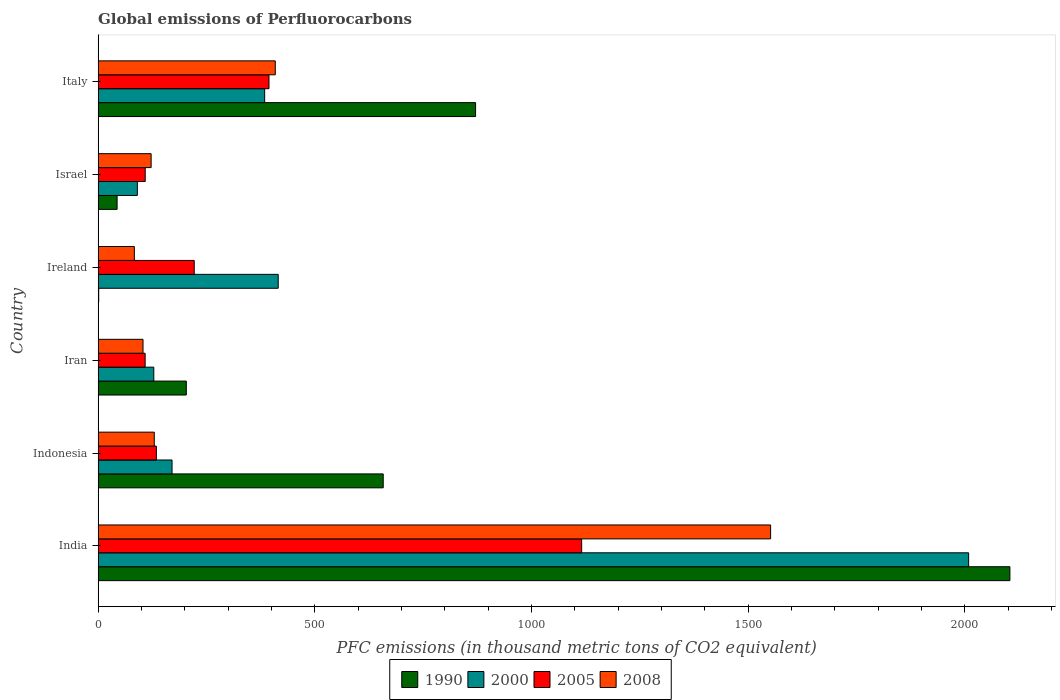How many different coloured bars are there?
Offer a very short reply. 4. How many groups of bars are there?
Your answer should be very brief. 6. Are the number of bars per tick equal to the number of legend labels?
Give a very brief answer. Yes. Are the number of bars on each tick of the Y-axis equal?
Keep it short and to the point. Yes. What is the label of the 1st group of bars from the top?
Give a very brief answer. Italy. In how many cases, is the number of bars for a given country not equal to the number of legend labels?
Keep it short and to the point. 0. What is the global emissions of Perfluorocarbons in 2005 in Israel?
Make the answer very short. 108.7. Across all countries, what is the maximum global emissions of Perfluorocarbons in 2000?
Give a very brief answer. 2008.8. Across all countries, what is the minimum global emissions of Perfluorocarbons in 2008?
Your answer should be compact. 83.6. In which country was the global emissions of Perfluorocarbons in 1990 minimum?
Make the answer very short. Ireland. What is the total global emissions of Perfluorocarbons in 2000 in the graph?
Provide a succinct answer. 3198.3. What is the difference between the global emissions of Perfluorocarbons in 2000 in India and that in Israel?
Your answer should be very brief. 1918.3. What is the difference between the global emissions of Perfluorocarbons in 2008 in Iran and the global emissions of Perfluorocarbons in 2005 in Indonesia?
Make the answer very short. -30.8. What is the average global emissions of Perfluorocarbons in 2005 per country?
Make the answer very short. 347.25. What is the difference between the global emissions of Perfluorocarbons in 1990 and global emissions of Perfluorocarbons in 2008 in Israel?
Provide a succinct answer. -78.5. In how many countries, is the global emissions of Perfluorocarbons in 1990 greater than 100 thousand metric tons?
Give a very brief answer. 4. What is the ratio of the global emissions of Perfluorocarbons in 1990 in Indonesia to that in Ireland?
Your answer should be compact. 469.93. What is the difference between the highest and the second highest global emissions of Perfluorocarbons in 1990?
Offer a terse response. 1233. What is the difference between the highest and the lowest global emissions of Perfluorocarbons in 2008?
Ensure brevity in your answer.  1468.2. In how many countries, is the global emissions of Perfluorocarbons in 2005 greater than the average global emissions of Perfluorocarbons in 2005 taken over all countries?
Your answer should be very brief. 2. Is the sum of the global emissions of Perfluorocarbons in 1990 in Indonesia and Ireland greater than the maximum global emissions of Perfluorocarbons in 2008 across all countries?
Your answer should be compact. No. What does the 4th bar from the bottom in Israel represents?
Your response must be concise. 2008. Is it the case that in every country, the sum of the global emissions of Perfluorocarbons in 2005 and global emissions of Perfluorocarbons in 2000 is greater than the global emissions of Perfluorocarbons in 2008?
Your answer should be compact. Yes. How many bars are there?
Offer a terse response. 24. How many countries are there in the graph?
Provide a short and direct response. 6. Are the values on the major ticks of X-axis written in scientific E-notation?
Ensure brevity in your answer.  No. Where does the legend appear in the graph?
Your response must be concise. Bottom center. How many legend labels are there?
Offer a very short reply. 4. What is the title of the graph?
Your answer should be very brief. Global emissions of Perfluorocarbons. Does "1988" appear as one of the legend labels in the graph?
Ensure brevity in your answer.  No. What is the label or title of the X-axis?
Provide a succinct answer. PFC emissions (in thousand metric tons of CO2 equivalent). What is the label or title of the Y-axis?
Provide a short and direct response. Country. What is the PFC emissions (in thousand metric tons of CO2 equivalent) in 1990 in India?
Offer a very short reply. 2104. What is the PFC emissions (in thousand metric tons of CO2 equivalent) of 2000 in India?
Your answer should be very brief. 2008.8. What is the PFC emissions (in thousand metric tons of CO2 equivalent) of 2005 in India?
Your response must be concise. 1115.8. What is the PFC emissions (in thousand metric tons of CO2 equivalent) of 2008 in India?
Your answer should be very brief. 1551.8. What is the PFC emissions (in thousand metric tons of CO2 equivalent) of 1990 in Indonesia?
Offer a terse response. 657.9. What is the PFC emissions (in thousand metric tons of CO2 equivalent) of 2000 in Indonesia?
Keep it short and to the point. 170.6. What is the PFC emissions (in thousand metric tons of CO2 equivalent) of 2005 in Indonesia?
Your answer should be very brief. 134.4. What is the PFC emissions (in thousand metric tons of CO2 equivalent) in 2008 in Indonesia?
Ensure brevity in your answer.  129.6. What is the PFC emissions (in thousand metric tons of CO2 equivalent) in 1990 in Iran?
Make the answer very short. 203.5. What is the PFC emissions (in thousand metric tons of CO2 equivalent) of 2000 in Iran?
Provide a short and direct response. 128.5. What is the PFC emissions (in thousand metric tons of CO2 equivalent) of 2005 in Iran?
Your response must be concise. 108.5. What is the PFC emissions (in thousand metric tons of CO2 equivalent) in 2008 in Iran?
Make the answer very short. 103.6. What is the PFC emissions (in thousand metric tons of CO2 equivalent) of 2000 in Ireland?
Your answer should be compact. 415.6. What is the PFC emissions (in thousand metric tons of CO2 equivalent) in 2005 in Ireland?
Your response must be concise. 221.8. What is the PFC emissions (in thousand metric tons of CO2 equivalent) in 2008 in Ireland?
Offer a very short reply. 83.6. What is the PFC emissions (in thousand metric tons of CO2 equivalent) in 1990 in Israel?
Your answer should be compact. 43.8. What is the PFC emissions (in thousand metric tons of CO2 equivalent) in 2000 in Israel?
Offer a terse response. 90.5. What is the PFC emissions (in thousand metric tons of CO2 equivalent) in 2005 in Israel?
Ensure brevity in your answer.  108.7. What is the PFC emissions (in thousand metric tons of CO2 equivalent) in 2008 in Israel?
Offer a very short reply. 122.3. What is the PFC emissions (in thousand metric tons of CO2 equivalent) in 1990 in Italy?
Offer a very short reply. 871. What is the PFC emissions (in thousand metric tons of CO2 equivalent) in 2000 in Italy?
Your answer should be very brief. 384.3. What is the PFC emissions (in thousand metric tons of CO2 equivalent) of 2005 in Italy?
Ensure brevity in your answer.  394.3. What is the PFC emissions (in thousand metric tons of CO2 equivalent) of 2008 in Italy?
Your answer should be very brief. 408.8. Across all countries, what is the maximum PFC emissions (in thousand metric tons of CO2 equivalent) in 1990?
Your answer should be compact. 2104. Across all countries, what is the maximum PFC emissions (in thousand metric tons of CO2 equivalent) of 2000?
Provide a short and direct response. 2008.8. Across all countries, what is the maximum PFC emissions (in thousand metric tons of CO2 equivalent) of 2005?
Your response must be concise. 1115.8. Across all countries, what is the maximum PFC emissions (in thousand metric tons of CO2 equivalent) of 2008?
Give a very brief answer. 1551.8. Across all countries, what is the minimum PFC emissions (in thousand metric tons of CO2 equivalent) of 2000?
Your answer should be compact. 90.5. Across all countries, what is the minimum PFC emissions (in thousand metric tons of CO2 equivalent) in 2005?
Provide a short and direct response. 108.5. Across all countries, what is the minimum PFC emissions (in thousand metric tons of CO2 equivalent) in 2008?
Keep it short and to the point. 83.6. What is the total PFC emissions (in thousand metric tons of CO2 equivalent) of 1990 in the graph?
Keep it short and to the point. 3881.6. What is the total PFC emissions (in thousand metric tons of CO2 equivalent) in 2000 in the graph?
Your response must be concise. 3198.3. What is the total PFC emissions (in thousand metric tons of CO2 equivalent) of 2005 in the graph?
Make the answer very short. 2083.5. What is the total PFC emissions (in thousand metric tons of CO2 equivalent) of 2008 in the graph?
Your response must be concise. 2399.7. What is the difference between the PFC emissions (in thousand metric tons of CO2 equivalent) of 1990 in India and that in Indonesia?
Ensure brevity in your answer.  1446.1. What is the difference between the PFC emissions (in thousand metric tons of CO2 equivalent) in 2000 in India and that in Indonesia?
Ensure brevity in your answer.  1838.2. What is the difference between the PFC emissions (in thousand metric tons of CO2 equivalent) in 2005 in India and that in Indonesia?
Keep it short and to the point. 981.4. What is the difference between the PFC emissions (in thousand metric tons of CO2 equivalent) in 2008 in India and that in Indonesia?
Offer a terse response. 1422.2. What is the difference between the PFC emissions (in thousand metric tons of CO2 equivalent) of 1990 in India and that in Iran?
Offer a terse response. 1900.5. What is the difference between the PFC emissions (in thousand metric tons of CO2 equivalent) in 2000 in India and that in Iran?
Provide a succinct answer. 1880.3. What is the difference between the PFC emissions (in thousand metric tons of CO2 equivalent) in 2005 in India and that in Iran?
Give a very brief answer. 1007.3. What is the difference between the PFC emissions (in thousand metric tons of CO2 equivalent) of 2008 in India and that in Iran?
Give a very brief answer. 1448.2. What is the difference between the PFC emissions (in thousand metric tons of CO2 equivalent) of 1990 in India and that in Ireland?
Provide a short and direct response. 2102.6. What is the difference between the PFC emissions (in thousand metric tons of CO2 equivalent) of 2000 in India and that in Ireland?
Offer a terse response. 1593.2. What is the difference between the PFC emissions (in thousand metric tons of CO2 equivalent) in 2005 in India and that in Ireland?
Offer a terse response. 894. What is the difference between the PFC emissions (in thousand metric tons of CO2 equivalent) of 2008 in India and that in Ireland?
Offer a very short reply. 1468.2. What is the difference between the PFC emissions (in thousand metric tons of CO2 equivalent) in 1990 in India and that in Israel?
Make the answer very short. 2060.2. What is the difference between the PFC emissions (in thousand metric tons of CO2 equivalent) in 2000 in India and that in Israel?
Offer a very short reply. 1918.3. What is the difference between the PFC emissions (in thousand metric tons of CO2 equivalent) in 2005 in India and that in Israel?
Offer a very short reply. 1007.1. What is the difference between the PFC emissions (in thousand metric tons of CO2 equivalent) of 2008 in India and that in Israel?
Offer a very short reply. 1429.5. What is the difference between the PFC emissions (in thousand metric tons of CO2 equivalent) of 1990 in India and that in Italy?
Make the answer very short. 1233. What is the difference between the PFC emissions (in thousand metric tons of CO2 equivalent) in 2000 in India and that in Italy?
Make the answer very short. 1624.5. What is the difference between the PFC emissions (in thousand metric tons of CO2 equivalent) of 2005 in India and that in Italy?
Your response must be concise. 721.5. What is the difference between the PFC emissions (in thousand metric tons of CO2 equivalent) of 2008 in India and that in Italy?
Your response must be concise. 1143. What is the difference between the PFC emissions (in thousand metric tons of CO2 equivalent) in 1990 in Indonesia and that in Iran?
Give a very brief answer. 454.4. What is the difference between the PFC emissions (in thousand metric tons of CO2 equivalent) in 2000 in Indonesia and that in Iran?
Provide a succinct answer. 42.1. What is the difference between the PFC emissions (in thousand metric tons of CO2 equivalent) of 2005 in Indonesia and that in Iran?
Give a very brief answer. 25.9. What is the difference between the PFC emissions (in thousand metric tons of CO2 equivalent) in 2008 in Indonesia and that in Iran?
Your answer should be very brief. 26. What is the difference between the PFC emissions (in thousand metric tons of CO2 equivalent) in 1990 in Indonesia and that in Ireland?
Provide a succinct answer. 656.5. What is the difference between the PFC emissions (in thousand metric tons of CO2 equivalent) in 2000 in Indonesia and that in Ireland?
Give a very brief answer. -245. What is the difference between the PFC emissions (in thousand metric tons of CO2 equivalent) in 2005 in Indonesia and that in Ireland?
Keep it short and to the point. -87.4. What is the difference between the PFC emissions (in thousand metric tons of CO2 equivalent) of 1990 in Indonesia and that in Israel?
Keep it short and to the point. 614.1. What is the difference between the PFC emissions (in thousand metric tons of CO2 equivalent) in 2000 in Indonesia and that in Israel?
Ensure brevity in your answer.  80.1. What is the difference between the PFC emissions (in thousand metric tons of CO2 equivalent) of 2005 in Indonesia and that in Israel?
Offer a very short reply. 25.7. What is the difference between the PFC emissions (in thousand metric tons of CO2 equivalent) in 1990 in Indonesia and that in Italy?
Keep it short and to the point. -213.1. What is the difference between the PFC emissions (in thousand metric tons of CO2 equivalent) in 2000 in Indonesia and that in Italy?
Ensure brevity in your answer.  -213.7. What is the difference between the PFC emissions (in thousand metric tons of CO2 equivalent) of 2005 in Indonesia and that in Italy?
Your answer should be very brief. -259.9. What is the difference between the PFC emissions (in thousand metric tons of CO2 equivalent) in 2008 in Indonesia and that in Italy?
Your answer should be compact. -279.2. What is the difference between the PFC emissions (in thousand metric tons of CO2 equivalent) of 1990 in Iran and that in Ireland?
Your answer should be very brief. 202.1. What is the difference between the PFC emissions (in thousand metric tons of CO2 equivalent) in 2000 in Iran and that in Ireland?
Make the answer very short. -287.1. What is the difference between the PFC emissions (in thousand metric tons of CO2 equivalent) of 2005 in Iran and that in Ireland?
Make the answer very short. -113.3. What is the difference between the PFC emissions (in thousand metric tons of CO2 equivalent) of 1990 in Iran and that in Israel?
Offer a very short reply. 159.7. What is the difference between the PFC emissions (in thousand metric tons of CO2 equivalent) in 2005 in Iran and that in Israel?
Keep it short and to the point. -0.2. What is the difference between the PFC emissions (in thousand metric tons of CO2 equivalent) in 2008 in Iran and that in Israel?
Your response must be concise. -18.7. What is the difference between the PFC emissions (in thousand metric tons of CO2 equivalent) in 1990 in Iran and that in Italy?
Offer a terse response. -667.5. What is the difference between the PFC emissions (in thousand metric tons of CO2 equivalent) of 2000 in Iran and that in Italy?
Provide a succinct answer. -255.8. What is the difference between the PFC emissions (in thousand metric tons of CO2 equivalent) of 2005 in Iran and that in Italy?
Your response must be concise. -285.8. What is the difference between the PFC emissions (in thousand metric tons of CO2 equivalent) in 2008 in Iran and that in Italy?
Provide a succinct answer. -305.2. What is the difference between the PFC emissions (in thousand metric tons of CO2 equivalent) in 1990 in Ireland and that in Israel?
Provide a short and direct response. -42.4. What is the difference between the PFC emissions (in thousand metric tons of CO2 equivalent) of 2000 in Ireland and that in Israel?
Your response must be concise. 325.1. What is the difference between the PFC emissions (in thousand metric tons of CO2 equivalent) of 2005 in Ireland and that in Israel?
Your answer should be compact. 113.1. What is the difference between the PFC emissions (in thousand metric tons of CO2 equivalent) of 2008 in Ireland and that in Israel?
Provide a short and direct response. -38.7. What is the difference between the PFC emissions (in thousand metric tons of CO2 equivalent) of 1990 in Ireland and that in Italy?
Provide a short and direct response. -869.6. What is the difference between the PFC emissions (in thousand metric tons of CO2 equivalent) of 2000 in Ireland and that in Italy?
Give a very brief answer. 31.3. What is the difference between the PFC emissions (in thousand metric tons of CO2 equivalent) in 2005 in Ireland and that in Italy?
Your answer should be very brief. -172.5. What is the difference between the PFC emissions (in thousand metric tons of CO2 equivalent) of 2008 in Ireland and that in Italy?
Your response must be concise. -325.2. What is the difference between the PFC emissions (in thousand metric tons of CO2 equivalent) of 1990 in Israel and that in Italy?
Your answer should be compact. -827.2. What is the difference between the PFC emissions (in thousand metric tons of CO2 equivalent) of 2000 in Israel and that in Italy?
Give a very brief answer. -293.8. What is the difference between the PFC emissions (in thousand metric tons of CO2 equivalent) of 2005 in Israel and that in Italy?
Your response must be concise. -285.6. What is the difference between the PFC emissions (in thousand metric tons of CO2 equivalent) in 2008 in Israel and that in Italy?
Your answer should be very brief. -286.5. What is the difference between the PFC emissions (in thousand metric tons of CO2 equivalent) of 1990 in India and the PFC emissions (in thousand metric tons of CO2 equivalent) of 2000 in Indonesia?
Your answer should be very brief. 1933.4. What is the difference between the PFC emissions (in thousand metric tons of CO2 equivalent) in 1990 in India and the PFC emissions (in thousand metric tons of CO2 equivalent) in 2005 in Indonesia?
Provide a short and direct response. 1969.6. What is the difference between the PFC emissions (in thousand metric tons of CO2 equivalent) of 1990 in India and the PFC emissions (in thousand metric tons of CO2 equivalent) of 2008 in Indonesia?
Offer a terse response. 1974.4. What is the difference between the PFC emissions (in thousand metric tons of CO2 equivalent) of 2000 in India and the PFC emissions (in thousand metric tons of CO2 equivalent) of 2005 in Indonesia?
Offer a very short reply. 1874.4. What is the difference between the PFC emissions (in thousand metric tons of CO2 equivalent) of 2000 in India and the PFC emissions (in thousand metric tons of CO2 equivalent) of 2008 in Indonesia?
Your response must be concise. 1879.2. What is the difference between the PFC emissions (in thousand metric tons of CO2 equivalent) in 2005 in India and the PFC emissions (in thousand metric tons of CO2 equivalent) in 2008 in Indonesia?
Make the answer very short. 986.2. What is the difference between the PFC emissions (in thousand metric tons of CO2 equivalent) of 1990 in India and the PFC emissions (in thousand metric tons of CO2 equivalent) of 2000 in Iran?
Provide a succinct answer. 1975.5. What is the difference between the PFC emissions (in thousand metric tons of CO2 equivalent) of 1990 in India and the PFC emissions (in thousand metric tons of CO2 equivalent) of 2005 in Iran?
Offer a very short reply. 1995.5. What is the difference between the PFC emissions (in thousand metric tons of CO2 equivalent) in 1990 in India and the PFC emissions (in thousand metric tons of CO2 equivalent) in 2008 in Iran?
Provide a short and direct response. 2000.4. What is the difference between the PFC emissions (in thousand metric tons of CO2 equivalent) of 2000 in India and the PFC emissions (in thousand metric tons of CO2 equivalent) of 2005 in Iran?
Offer a very short reply. 1900.3. What is the difference between the PFC emissions (in thousand metric tons of CO2 equivalent) in 2000 in India and the PFC emissions (in thousand metric tons of CO2 equivalent) in 2008 in Iran?
Your response must be concise. 1905.2. What is the difference between the PFC emissions (in thousand metric tons of CO2 equivalent) of 2005 in India and the PFC emissions (in thousand metric tons of CO2 equivalent) of 2008 in Iran?
Keep it short and to the point. 1012.2. What is the difference between the PFC emissions (in thousand metric tons of CO2 equivalent) of 1990 in India and the PFC emissions (in thousand metric tons of CO2 equivalent) of 2000 in Ireland?
Offer a very short reply. 1688.4. What is the difference between the PFC emissions (in thousand metric tons of CO2 equivalent) of 1990 in India and the PFC emissions (in thousand metric tons of CO2 equivalent) of 2005 in Ireland?
Your answer should be compact. 1882.2. What is the difference between the PFC emissions (in thousand metric tons of CO2 equivalent) in 1990 in India and the PFC emissions (in thousand metric tons of CO2 equivalent) in 2008 in Ireland?
Provide a succinct answer. 2020.4. What is the difference between the PFC emissions (in thousand metric tons of CO2 equivalent) in 2000 in India and the PFC emissions (in thousand metric tons of CO2 equivalent) in 2005 in Ireland?
Offer a very short reply. 1787. What is the difference between the PFC emissions (in thousand metric tons of CO2 equivalent) in 2000 in India and the PFC emissions (in thousand metric tons of CO2 equivalent) in 2008 in Ireland?
Your answer should be compact. 1925.2. What is the difference between the PFC emissions (in thousand metric tons of CO2 equivalent) of 2005 in India and the PFC emissions (in thousand metric tons of CO2 equivalent) of 2008 in Ireland?
Provide a short and direct response. 1032.2. What is the difference between the PFC emissions (in thousand metric tons of CO2 equivalent) in 1990 in India and the PFC emissions (in thousand metric tons of CO2 equivalent) in 2000 in Israel?
Keep it short and to the point. 2013.5. What is the difference between the PFC emissions (in thousand metric tons of CO2 equivalent) in 1990 in India and the PFC emissions (in thousand metric tons of CO2 equivalent) in 2005 in Israel?
Offer a terse response. 1995.3. What is the difference between the PFC emissions (in thousand metric tons of CO2 equivalent) in 1990 in India and the PFC emissions (in thousand metric tons of CO2 equivalent) in 2008 in Israel?
Offer a terse response. 1981.7. What is the difference between the PFC emissions (in thousand metric tons of CO2 equivalent) in 2000 in India and the PFC emissions (in thousand metric tons of CO2 equivalent) in 2005 in Israel?
Make the answer very short. 1900.1. What is the difference between the PFC emissions (in thousand metric tons of CO2 equivalent) in 2000 in India and the PFC emissions (in thousand metric tons of CO2 equivalent) in 2008 in Israel?
Your response must be concise. 1886.5. What is the difference between the PFC emissions (in thousand metric tons of CO2 equivalent) of 2005 in India and the PFC emissions (in thousand metric tons of CO2 equivalent) of 2008 in Israel?
Your response must be concise. 993.5. What is the difference between the PFC emissions (in thousand metric tons of CO2 equivalent) in 1990 in India and the PFC emissions (in thousand metric tons of CO2 equivalent) in 2000 in Italy?
Your response must be concise. 1719.7. What is the difference between the PFC emissions (in thousand metric tons of CO2 equivalent) of 1990 in India and the PFC emissions (in thousand metric tons of CO2 equivalent) of 2005 in Italy?
Your answer should be very brief. 1709.7. What is the difference between the PFC emissions (in thousand metric tons of CO2 equivalent) in 1990 in India and the PFC emissions (in thousand metric tons of CO2 equivalent) in 2008 in Italy?
Offer a very short reply. 1695.2. What is the difference between the PFC emissions (in thousand metric tons of CO2 equivalent) of 2000 in India and the PFC emissions (in thousand metric tons of CO2 equivalent) of 2005 in Italy?
Provide a short and direct response. 1614.5. What is the difference between the PFC emissions (in thousand metric tons of CO2 equivalent) in 2000 in India and the PFC emissions (in thousand metric tons of CO2 equivalent) in 2008 in Italy?
Provide a succinct answer. 1600. What is the difference between the PFC emissions (in thousand metric tons of CO2 equivalent) of 2005 in India and the PFC emissions (in thousand metric tons of CO2 equivalent) of 2008 in Italy?
Provide a succinct answer. 707. What is the difference between the PFC emissions (in thousand metric tons of CO2 equivalent) of 1990 in Indonesia and the PFC emissions (in thousand metric tons of CO2 equivalent) of 2000 in Iran?
Provide a succinct answer. 529.4. What is the difference between the PFC emissions (in thousand metric tons of CO2 equivalent) of 1990 in Indonesia and the PFC emissions (in thousand metric tons of CO2 equivalent) of 2005 in Iran?
Provide a succinct answer. 549.4. What is the difference between the PFC emissions (in thousand metric tons of CO2 equivalent) in 1990 in Indonesia and the PFC emissions (in thousand metric tons of CO2 equivalent) in 2008 in Iran?
Ensure brevity in your answer.  554.3. What is the difference between the PFC emissions (in thousand metric tons of CO2 equivalent) in 2000 in Indonesia and the PFC emissions (in thousand metric tons of CO2 equivalent) in 2005 in Iran?
Your response must be concise. 62.1. What is the difference between the PFC emissions (in thousand metric tons of CO2 equivalent) in 2000 in Indonesia and the PFC emissions (in thousand metric tons of CO2 equivalent) in 2008 in Iran?
Offer a terse response. 67. What is the difference between the PFC emissions (in thousand metric tons of CO2 equivalent) in 2005 in Indonesia and the PFC emissions (in thousand metric tons of CO2 equivalent) in 2008 in Iran?
Give a very brief answer. 30.8. What is the difference between the PFC emissions (in thousand metric tons of CO2 equivalent) in 1990 in Indonesia and the PFC emissions (in thousand metric tons of CO2 equivalent) in 2000 in Ireland?
Keep it short and to the point. 242.3. What is the difference between the PFC emissions (in thousand metric tons of CO2 equivalent) in 1990 in Indonesia and the PFC emissions (in thousand metric tons of CO2 equivalent) in 2005 in Ireland?
Ensure brevity in your answer.  436.1. What is the difference between the PFC emissions (in thousand metric tons of CO2 equivalent) in 1990 in Indonesia and the PFC emissions (in thousand metric tons of CO2 equivalent) in 2008 in Ireland?
Your answer should be very brief. 574.3. What is the difference between the PFC emissions (in thousand metric tons of CO2 equivalent) in 2000 in Indonesia and the PFC emissions (in thousand metric tons of CO2 equivalent) in 2005 in Ireland?
Keep it short and to the point. -51.2. What is the difference between the PFC emissions (in thousand metric tons of CO2 equivalent) in 2005 in Indonesia and the PFC emissions (in thousand metric tons of CO2 equivalent) in 2008 in Ireland?
Give a very brief answer. 50.8. What is the difference between the PFC emissions (in thousand metric tons of CO2 equivalent) in 1990 in Indonesia and the PFC emissions (in thousand metric tons of CO2 equivalent) in 2000 in Israel?
Ensure brevity in your answer.  567.4. What is the difference between the PFC emissions (in thousand metric tons of CO2 equivalent) in 1990 in Indonesia and the PFC emissions (in thousand metric tons of CO2 equivalent) in 2005 in Israel?
Provide a succinct answer. 549.2. What is the difference between the PFC emissions (in thousand metric tons of CO2 equivalent) of 1990 in Indonesia and the PFC emissions (in thousand metric tons of CO2 equivalent) of 2008 in Israel?
Your response must be concise. 535.6. What is the difference between the PFC emissions (in thousand metric tons of CO2 equivalent) in 2000 in Indonesia and the PFC emissions (in thousand metric tons of CO2 equivalent) in 2005 in Israel?
Offer a terse response. 61.9. What is the difference between the PFC emissions (in thousand metric tons of CO2 equivalent) of 2000 in Indonesia and the PFC emissions (in thousand metric tons of CO2 equivalent) of 2008 in Israel?
Provide a short and direct response. 48.3. What is the difference between the PFC emissions (in thousand metric tons of CO2 equivalent) of 1990 in Indonesia and the PFC emissions (in thousand metric tons of CO2 equivalent) of 2000 in Italy?
Offer a very short reply. 273.6. What is the difference between the PFC emissions (in thousand metric tons of CO2 equivalent) of 1990 in Indonesia and the PFC emissions (in thousand metric tons of CO2 equivalent) of 2005 in Italy?
Keep it short and to the point. 263.6. What is the difference between the PFC emissions (in thousand metric tons of CO2 equivalent) in 1990 in Indonesia and the PFC emissions (in thousand metric tons of CO2 equivalent) in 2008 in Italy?
Offer a terse response. 249.1. What is the difference between the PFC emissions (in thousand metric tons of CO2 equivalent) in 2000 in Indonesia and the PFC emissions (in thousand metric tons of CO2 equivalent) in 2005 in Italy?
Give a very brief answer. -223.7. What is the difference between the PFC emissions (in thousand metric tons of CO2 equivalent) in 2000 in Indonesia and the PFC emissions (in thousand metric tons of CO2 equivalent) in 2008 in Italy?
Offer a very short reply. -238.2. What is the difference between the PFC emissions (in thousand metric tons of CO2 equivalent) of 2005 in Indonesia and the PFC emissions (in thousand metric tons of CO2 equivalent) of 2008 in Italy?
Ensure brevity in your answer.  -274.4. What is the difference between the PFC emissions (in thousand metric tons of CO2 equivalent) of 1990 in Iran and the PFC emissions (in thousand metric tons of CO2 equivalent) of 2000 in Ireland?
Your answer should be very brief. -212.1. What is the difference between the PFC emissions (in thousand metric tons of CO2 equivalent) of 1990 in Iran and the PFC emissions (in thousand metric tons of CO2 equivalent) of 2005 in Ireland?
Provide a succinct answer. -18.3. What is the difference between the PFC emissions (in thousand metric tons of CO2 equivalent) in 1990 in Iran and the PFC emissions (in thousand metric tons of CO2 equivalent) in 2008 in Ireland?
Provide a succinct answer. 119.9. What is the difference between the PFC emissions (in thousand metric tons of CO2 equivalent) of 2000 in Iran and the PFC emissions (in thousand metric tons of CO2 equivalent) of 2005 in Ireland?
Give a very brief answer. -93.3. What is the difference between the PFC emissions (in thousand metric tons of CO2 equivalent) in 2000 in Iran and the PFC emissions (in thousand metric tons of CO2 equivalent) in 2008 in Ireland?
Make the answer very short. 44.9. What is the difference between the PFC emissions (in thousand metric tons of CO2 equivalent) in 2005 in Iran and the PFC emissions (in thousand metric tons of CO2 equivalent) in 2008 in Ireland?
Keep it short and to the point. 24.9. What is the difference between the PFC emissions (in thousand metric tons of CO2 equivalent) of 1990 in Iran and the PFC emissions (in thousand metric tons of CO2 equivalent) of 2000 in Israel?
Ensure brevity in your answer.  113. What is the difference between the PFC emissions (in thousand metric tons of CO2 equivalent) of 1990 in Iran and the PFC emissions (in thousand metric tons of CO2 equivalent) of 2005 in Israel?
Offer a terse response. 94.8. What is the difference between the PFC emissions (in thousand metric tons of CO2 equivalent) of 1990 in Iran and the PFC emissions (in thousand metric tons of CO2 equivalent) of 2008 in Israel?
Keep it short and to the point. 81.2. What is the difference between the PFC emissions (in thousand metric tons of CO2 equivalent) in 2000 in Iran and the PFC emissions (in thousand metric tons of CO2 equivalent) in 2005 in Israel?
Your response must be concise. 19.8. What is the difference between the PFC emissions (in thousand metric tons of CO2 equivalent) of 2000 in Iran and the PFC emissions (in thousand metric tons of CO2 equivalent) of 2008 in Israel?
Your answer should be compact. 6.2. What is the difference between the PFC emissions (in thousand metric tons of CO2 equivalent) of 1990 in Iran and the PFC emissions (in thousand metric tons of CO2 equivalent) of 2000 in Italy?
Keep it short and to the point. -180.8. What is the difference between the PFC emissions (in thousand metric tons of CO2 equivalent) of 1990 in Iran and the PFC emissions (in thousand metric tons of CO2 equivalent) of 2005 in Italy?
Offer a terse response. -190.8. What is the difference between the PFC emissions (in thousand metric tons of CO2 equivalent) in 1990 in Iran and the PFC emissions (in thousand metric tons of CO2 equivalent) in 2008 in Italy?
Your answer should be compact. -205.3. What is the difference between the PFC emissions (in thousand metric tons of CO2 equivalent) in 2000 in Iran and the PFC emissions (in thousand metric tons of CO2 equivalent) in 2005 in Italy?
Keep it short and to the point. -265.8. What is the difference between the PFC emissions (in thousand metric tons of CO2 equivalent) of 2000 in Iran and the PFC emissions (in thousand metric tons of CO2 equivalent) of 2008 in Italy?
Your answer should be compact. -280.3. What is the difference between the PFC emissions (in thousand metric tons of CO2 equivalent) of 2005 in Iran and the PFC emissions (in thousand metric tons of CO2 equivalent) of 2008 in Italy?
Offer a terse response. -300.3. What is the difference between the PFC emissions (in thousand metric tons of CO2 equivalent) of 1990 in Ireland and the PFC emissions (in thousand metric tons of CO2 equivalent) of 2000 in Israel?
Your answer should be compact. -89.1. What is the difference between the PFC emissions (in thousand metric tons of CO2 equivalent) in 1990 in Ireland and the PFC emissions (in thousand metric tons of CO2 equivalent) in 2005 in Israel?
Offer a very short reply. -107.3. What is the difference between the PFC emissions (in thousand metric tons of CO2 equivalent) in 1990 in Ireland and the PFC emissions (in thousand metric tons of CO2 equivalent) in 2008 in Israel?
Offer a very short reply. -120.9. What is the difference between the PFC emissions (in thousand metric tons of CO2 equivalent) of 2000 in Ireland and the PFC emissions (in thousand metric tons of CO2 equivalent) of 2005 in Israel?
Offer a terse response. 306.9. What is the difference between the PFC emissions (in thousand metric tons of CO2 equivalent) of 2000 in Ireland and the PFC emissions (in thousand metric tons of CO2 equivalent) of 2008 in Israel?
Ensure brevity in your answer.  293.3. What is the difference between the PFC emissions (in thousand metric tons of CO2 equivalent) of 2005 in Ireland and the PFC emissions (in thousand metric tons of CO2 equivalent) of 2008 in Israel?
Offer a terse response. 99.5. What is the difference between the PFC emissions (in thousand metric tons of CO2 equivalent) of 1990 in Ireland and the PFC emissions (in thousand metric tons of CO2 equivalent) of 2000 in Italy?
Ensure brevity in your answer.  -382.9. What is the difference between the PFC emissions (in thousand metric tons of CO2 equivalent) in 1990 in Ireland and the PFC emissions (in thousand metric tons of CO2 equivalent) in 2005 in Italy?
Make the answer very short. -392.9. What is the difference between the PFC emissions (in thousand metric tons of CO2 equivalent) of 1990 in Ireland and the PFC emissions (in thousand metric tons of CO2 equivalent) of 2008 in Italy?
Your answer should be very brief. -407.4. What is the difference between the PFC emissions (in thousand metric tons of CO2 equivalent) in 2000 in Ireland and the PFC emissions (in thousand metric tons of CO2 equivalent) in 2005 in Italy?
Offer a terse response. 21.3. What is the difference between the PFC emissions (in thousand metric tons of CO2 equivalent) of 2000 in Ireland and the PFC emissions (in thousand metric tons of CO2 equivalent) of 2008 in Italy?
Ensure brevity in your answer.  6.8. What is the difference between the PFC emissions (in thousand metric tons of CO2 equivalent) of 2005 in Ireland and the PFC emissions (in thousand metric tons of CO2 equivalent) of 2008 in Italy?
Give a very brief answer. -187. What is the difference between the PFC emissions (in thousand metric tons of CO2 equivalent) of 1990 in Israel and the PFC emissions (in thousand metric tons of CO2 equivalent) of 2000 in Italy?
Make the answer very short. -340.5. What is the difference between the PFC emissions (in thousand metric tons of CO2 equivalent) of 1990 in Israel and the PFC emissions (in thousand metric tons of CO2 equivalent) of 2005 in Italy?
Provide a short and direct response. -350.5. What is the difference between the PFC emissions (in thousand metric tons of CO2 equivalent) of 1990 in Israel and the PFC emissions (in thousand metric tons of CO2 equivalent) of 2008 in Italy?
Keep it short and to the point. -365. What is the difference between the PFC emissions (in thousand metric tons of CO2 equivalent) of 2000 in Israel and the PFC emissions (in thousand metric tons of CO2 equivalent) of 2005 in Italy?
Offer a terse response. -303.8. What is the difference between the PFC emissions (in thousand metric tons of CO2 equivalent) of 2000 in Israel and the PFC emissions (in thousand metric tons of CO2 equivalent) of 2008 in Italy?
Provide a succinct answer. -318.3. What is the difference between the PFC emissions (in thousand metric tons of CO2 equivalent) of 2005 in Israel and the PFC emissions (in thousand metric tons of CO2 equivalent) of 2008 in Italy?
Your response must be concise. -300.1. What is the average PFC emissions (in thousand metric tons of CO2 equivalent) of 1990 per country?
Ensure brevity in your answer.  646.93. What is the average PFC emissions (in thousand metric tons of CO2 equivalent) of 2000 per country?
Your answer should be compact. 533.05. What is the average PFC emissions (in thousand metric tons of CO2 equivalent) of 2005 per country?
Give a very brief answer. 347.25. What is the average PFC emissions (in thousand metric tons of CO2 equivalent) in 2008 per country?
Offer a very short reply. 399.95. What is the difference between the PFC emissions (in thousand metric tons of CO2 equivalent) in 1990 and PFC emissions (in thousand metric tons of CO2 equivalent) in 2000 in India?
Ensure brevity in your answer.  95.2. What is the difference between the PFC emissions (in thousand metric tons of CO2 equivalent) of 1990 and PFC emissions (in thousand metric tons of CO2 equivalent) of 2005 in India?
Your answer should be very brief. 988.2. What is the difference between the PFC emissions (in thousand metric tons of CO2 equivalent) in 1990 and PFC emissions (in thousand metric tons of CO2 equivalent) in 2008 in India?
Make the answer very short. 552.2. What is the difference between the PFC emissions (in thousand metric tons of CO2 equivalent) of 2000 and PFC emissions (in thousand metric tons of CO2 equivalent) of 2005 in India?
Provide a succinct answer. 893. What is the difference between the PFC emissions (in thousand metric tons of CO2 equivalent) in 2000 and PFC emissions (in thousand metric tons of CO2 equivalent) in 2008 in India?
Your answer should be compact. 457. What is the difference between the PFC emissions (in thousand metric tons of CO2 equivalent) in 2005 and PFC emissions (in thousand metric tons of CO2 equivalent) in 2008 in India?
Provide a short and direct response. -436. What is the difference between the PFC emissions (in thousand metric tons of CO2 equivalent) of 1990 and PFC emissions (in thousand metric tons of CO2 equivalent) of 2000 in Indonesia?
Give a very brief answer. 487.3. What is the difference between the PFC emissions (in thousand metric tons of CO2 equivalent) of 1990 and PFC emissions (in thousand metric tons of CO2 equivalent) of 2005 in Indonesia?
Provide a succinct answer. 523.5. What is the difference between the PFC emissions (in thousand metric tons of CO2 equivalent) of 1990 and PFC emissions (in thousand metric tons of CO2 equivalent) of 2008 in Indonesia?
Your response must be concise. 528.3. What is the difference between the PFC emissions (in thousand metric tons of CO2 equivalent) of 2000 and PFC emissions (in thousand metric tons of CO2 equivalent) of 2005 in Indonesia?
Ensure brevity in your answer.  36.2. What is the difference between the PFC emissions (in thousand metric tons of CO2 equivalent) in 1990 and PFC emissions (in thousand metric tons of CO2 equivalent) in 2008 in Iran?
Ensure brevity in your answer.  99.9. What is the difference between the PFC emissions (in thousand metric tons of CO2 equivalent) in 2000 and PFC emissions (in thousand metric tons of CO2 equivalent) in 2008 in Iran?
Provide a succinct answer. 24.9. What is the difference between the PFC emissions (in thousand metric tons of CO2 equivalent) of 2005 and PFC emissions (in thousand metric tons of CO2 equivalent) of 2008 in Iran?
Keep it short and to the point. 4.9. What is the difference between the PFC emissions (in thousand metric tons of CO2 equivalent) in 1990 and PFC emissions (in thousand metric tons of CO2 equivalent) in 2000 in Ireland?
Your answer should be very brief. -414.2. What is the difference between the PFC emissions (in thousand metric tons of CO2 equivalent) of 1990 and PFC emissions (in thousand metric tons of CO2 equivalent) of 2005 in Ireland?
Your answer should be compact. -220.4. What is the difference between the PFC emissions (in thousand metric tons of CO2 equivalent) in 1990 and PFC emissions (in thousand metric tons of CO2 equivalent) in 2008 in Ireland?
Your answer should be very brief. -82.2. What is the difference between the PFC emissions (in thousand metric tons of CO2 equivalent) in 2000 and PFC emissions (in thousand metric tons of CO2 equivalent) in 2005 in Ireland?
Offer a terse response. 193.8. What is the difference between the PFC emissions (in thousand metric tons of CO2 equivalent) in 2000 and PFC emissions (in thousand metric tons of CO2 equivalent) in 2008 in Ireland?
Ensure brevity in your answer.  332. What is the difference between the PFC emissions (in thousand metric tons of CO2 equivalent) in 2005 and PFC emissions (in thousand metric tons of CO2 equivalent) in 2008 in Ireland?
Keep it short and to the point. 138.2. What is the difference between the PFC emissions (in thousand metric tons of CO2 equivalent) in 1990 and PFC emissions (in thousand metric tons of CO2 equivalent) in 2000 in Israel?
Make the answer very short. -46.7. What is the difference between the PFC emissions (in thousand metric tons of CO2 equivalent) of 1990 and PFC emissions (in thousand metric tons of CO2 equivalent) of 2005 in Israel?
Provide a short and direct response. -64.9. What is the difference between the PFC emissions (in thousand metric tons of CO2 equivalent) in 1990 and PFC emissions (in thousand metric tons of CO2 equivalent) in 2008 in Israel?
Keep it short and to the point. -78.5. What is the difference between the PFC emissions (in thousand metric tons of CO2 equivalent) in 2000 and PFC emissions (in thousand metric tons of CO2 equivalent) in 2005 in Israel?
Keep it short and to the point. -18.2. What is the difference between the PFC emissions (in thousand metric tons of CO2 equivalent) of 2000 and PFC emissions (in thousand metric tons of CO2 equivalent) of 2008 in Israel?
Offer a terse response. -31.8. What is the difference between the PFC emissions (in thousand metric tons of CO2 equivalent) of 2005 and PFC emissions (in thousand metric tons of CO2 equivalent) of 2008 in Israel?
Your response must be concise. -13.6. What is the difference between the PFC emissions (in thousand metric tons of CO2 equivalent) of 1990 and PFC emissions (in thousand metric tons of CO2 equivalent) of 2000 in Italy?
Offer a terse response. 486.7. What is the difference between the PFC emissions (in thousand metric tons of CO2 equivalent) in 1990 and PFC emissions (in thousand metric tons of CO2 equivalent) in 2005 in Italy?
Make the answer very short. 476.7. What is the difference between the PFC emissions (in thousand metric tons of CO2 equivalent) of 1990 and PFC emissions (in thousand metric tons of CO2 equivalent) of 2008 in Italy?
Your answer should be very brief. 462.2. What is the difference between the PFC emissions (in thousand metric tons of CO2 equivalent) in 2000 and PFC emissions (in thousand metric tons of CO2 equivalent) in 2005 in Italy?
Your response must be concise. -10. What is the difference between the PFC emissions (in thousand metric tons of CO2 equivalent) in 2000 and PFC emissions (in thousand metric tons of CO2 equivalent) in 2008 in Italy?
Provide a short and direct response. -24.5. What is the difference between the PFC emissions (in thousand metric tons of CO2 equivalent) in 2005 and PFC emissions (in thousand metric tons of CO2 equivalent) in 2008 in Italy?
Keep it short and to the point. -14.5. What is the ratio of the PFC emissions (in thousand metric tons of CO2 equivalent) in 1990 in India to that in Indonesia?
Your answer should be compact. 3.2. What is the ratio of the PFC emissions (in thousand metric tons of CO2 equivalent) in 2000 in India to that in Indonesia?
Make the answer very short. 11.77. What is the ratio of the PFC emissions (in thousand metric tons of CO2 equivalent) in 2005 in India to that in Indonesia?
Your answer should be very brief. 8.3. What is the ratio of the PFC emissions (in thousand metric tons of CO2 equivalent) in 2008 in India to that in Indonesia?
Make the answer very short. 11.97. What is the ratio of the PFC emissions (in thousand metric tons of CO2 equivalent) of 1990 in India to that in Iran?
Make the answer very short. 10.34. What is the ratio of the PFC emissions (in thousand metric tons of CO2 equivalent) of 2000 in India to that in Iran?
Provide a short and direct response. 15.63. What is the ratio of the PFC emissions (in thousand metric tons of CO2 equivalent) in 2005 in India to that in Iran?
Offer a terse response. 10.28. What is the ratio of the PFC emissions (in thousand metric tons of CO2 equivalent) of 2008 in India to that in Iran?
Provide a succinct answer. 14.98. What is the ratio of the PFC emissions (in thousand metric tons of CO2 equivalent) of 1990 in India to that in Ireland?
Provide a short and direct response. 1502.86. What is the ratio of the PFC emissions (in thousand metric tons of CO2 equivalent) in 2000 in India to that in Ireland?
Your response must be concise. 4.83. What is the ratio of the PFC emissions (in thousand metric tons of CO2 equivalent) of 2005 in India to that in Ireland?
Provide a short and direct response. 5.03. What is the ratio of the PFC emissions (in thousand metric tons of CO2 equivalent) in 2008 in India to that in Ireland?
Provide a succinct answer. 18.56. What is the ratio of the PFC emissions (in thousand metric tons of CO2 equivalent) in 1990 in India to that in Israel?
Give a very brief answer. 48.04. What is the ratio of the PFC emissions (in thousand metric tons of CO2 equivalent) in 2000 in India to that in Israel?
Offer a very short reply. 22.2. What is the ratio of the PFC emissions (in thousand metric tons of CO2 equivalent) in 2005 in India to that in Israel?
Make the answer very short. 10.26. What is the ratio of the PFC emissions (in thousand metric tons of CO2 equivalent) of 2008 in India to that in Israel?
Your answer should be compact. 12.69. What is the ratio of the PFC emissions (in thousand metric tons of CO2 equivalent) of 1990 in India to that in Italy?
Give a very brief answer. 2.42. What is the ratio of the PFC emissions (in thousand metric tons of CO2 equivalent) in 2000 in India to that in Italy?
Offer a terse response. 5.23. What is the ratio of the PFC emissions (in thousand metric tons of CO2 equivalent) of 2005 in India to that in Italy?
Make the answer very short. 2.83. What is the ratio of the PFC emissions (in thousand metric tons of CO2 equivalent) in 2008 in India to that in Italy?
Offer a very short reply. 3.8. What is the ratio of the PFC emissions (in thousand metric tons of CO2 equivalent) of 1990 in Indonesia to that in Iran?
Provide a succinct answer. 3.23. What is the ratio of the PFC emissions (in thousand metric tons of CO2 equivalent) of 2000 in Indonesia to that in Iran?
Your response must be concise. 1.33. What is the ratio of the PFC emissions (in thousand metric tons of CO2 equivalent) in 2005 in Indonesia to that in Iran?
Your answer should be very brief. 1.24. What is the ratio of the PFC emissions (in thousand metric tons of CO2 equivalent) of 2008 in Indonesia to that in Iran?
Make the answer very short. 1.25. What is the ratio of the PFC emissions (in thousand metric tons of CO2 equivalent) of 1990 in Indonesia to that in Ireland?
Provide a short and direct response. 469.93. What is the ratio of the PFC emissions (in thousand metric tons of CO2 equivalent) of 2000 in Indonesia to that in Ireland?
Make the answer very short. 0.41. What is the ratio of the PFC emissions (in thousand metric tons of CO2 equivalent) in 2005 in Indonesia to that in Ireland?
Your answer should be compact. 0.61. What is the ratio of the PFC emissions (in thousand metric tons of CO2 equivalent) in 2008 in Indonesia to that in Ireland?
Ensure brevity in your answer.  1.55. What is the ratio of the PFC emissions (in thousand metric tons of CO2 equivalent) of 1990 in Indonesia to that in Israel?
Your answer should be very brief. 15.02. What is the ratio of the PFC emissions (in thousand metric tons of CO2 equivalent) of 2000 in Indonesia to that in Israel?
Offer a very short reply. 1.89. What is the ratio of the PFC emissions (in thousand metric tons of CO2 equivalent) in 2005 in Indonesia to that in Israel?
Provide a succinct answer. 1.24. What is the ratio of the PFC emissions (in thousand metric tons of CO2 equivalent) of 2008 in Indonesia to that in Israel?
Ensure brevity in your answer.  1.06. What is the ratio of the PFC emissions (in thousand metric tons of CO2 equivalent) in 1990 in Indonesia to that in Italy?
Provide a short and direct response. 0.76. What is the ratio of the PFC emissions (in thousand metric tons of CO2 equivalent) in 2000 in Indonesia to that in Italy?
Offer a very short reply. 0.44. What is the ratio of the PFC emissions (in thousand metric tons of CO2 equivalent) of 2005 in Indonesia to that in Italy?
Offer a terse response. 0.34. What is the ratio of the PFC emissions (in thousand metric tons of CO2 equivalent) in 2008 in Indonesia to that in Italy?
Your answer should be compact. 0.32. What is the ratio of the PFC emissions (in thousand metric tons of CO2 equivalent) in 1990 in Iran to that in Ireland?
Make the answer very short. 145.36. What is the ratio of the PFC emissions (in thousand metric tons of CO2 equivalent) of 2000 in Iran to that in Ireland?
Your response must be concise. 0.31. What is the ratio of the PFC emissions (in thousand metric tons of CO2 equivalent) of 2005 in Iran to that in Ireland?
Your response must be concise. 0.49. What is the ratio of the PFC emissions (in thousand metric tons of CO2 equivalent) in 2008 in Iran to that in Ireland?
Provide a succinct answer. 1.24. What is the ratio of the PFC emissions (in thousand metric tons of CO2 equivalent) in 1990 in Iran to that in Israel?
Keep it short and to the point. 4.65. What is the ratio of the PFC emissions (in thousand metric tons of CO2 equivalent) of 2000 in Iran to that in Israel?
Offer a terse response. 1.42. What is the ratio of the PFC emissions (in thousand metric tons of CO2 equivalent) of 2008 in Iran to that in Israel?
Your response must be concise. 0.85. What is the ratio of the PFC emissions (in thousand metric tons of CO2 equivalent) of 1990 in Iran to that in Italy?
Make the answer very short. 0.23. What is the ratio of the PFC emissions (in thousand metric tons of CO2 equivalent) of 2000 in Iran to that in Italy?
Provide a short and direct response. 0.33. What is the ratio of the PFC emissions (in thousand metric tons of CO2 equivalent) of 2005 in Iran to that in Italy?
Your answer should be very brief. 0.28. What is the ratio of the PFC emissions (in thousand metric tons of CO2 equivalent) of 2008 in Iran to that in Italy?
Ensure brevity in your answer.  0.25. What is the ratio of the PFC emissions (in thousand metric tons of CO2 equivalent) in 1990 in Ireland to that in Israel?
Provide a short and direct response. 0.03. What is the ratio of the PFC emissions (in thousand metric tons of CO2 equivalent) in 2000 in Ireland to that in Israel?
Provide a short and direct response. 4.59. What is the ratio of the PFC emissions (in thousand metric tons of CO2 equivalent) in 2005 in Ireland to that in Israel?
Provide a short and direct response. 2.04. What is the ratio of the PFC emissions (in thousand metric tons of CO2 equivalent) in 2008 in Ireland to that in Israel?
Provide a succinct answer. 0.68. What is the ratio of the PFC emissions (in thousand metric tons of CO2 equivalent) of 1990 in Ireland to that in Italy?
Keep it short and to the point. 0. What is the ratio of the PFC emissions (in thousand metric tons of CO2 equivalent) in 2000 in Ireland to that in Italy?
Your response must be concise. 1.08. What is the ratio of the PFC emissions (in thousand metric tons of CO2 equivalent) in 2005 in Ireland to that in Italy?
Provide a short and direct response. 0.56. What is the ratio of the PFC emissions (in thousand metric tons of CO2 equivalent) of 2008 in Ireland to that in Italy?
Provide a short and direct response. 0.2. What is the ratio of the PFC emissions (in thousand metric tons of CO2 equivalent) in 1990 in Israel to that in Italy?
Provide a short and direct response. 0.05. What is the ratio of the PFC emissions (in thousand metric tons of CO2 equivalent) of 2000 in Israel to that in Italy?
Provide a short and direct response. 0.24. What is the ratio of the PFC emissions (in thousand metric tons of CO2 equivalent) in 2005 in Israel to that in Italy?
Your answer should be compact. 0.28. What is the ratio of the PFC emissions (in thousand metric tons of CO2 equivalent) in 2008 in Israel to that in Italy?
Ensure brevity in your answer.  0.3. What is the difference between the highest and the second highest PFC emissions (in thousand metric tons of CO2 equivalent) in 1990?
Provide a succinct answer. 1233. What is the difference between the highest and the second highest PFC emissions (in thousand metric tons of CO2 equivalent) of 2000?
Your answer should be very brief. 1593.2. What is the difference between the highest and the second highest PFC emissions (in thousand metric tons of CO2 equivalent) of 2005?
Offer a very short reply. 721.5. What is the difference between the highest and the second highest PFC emissions (in thousand metric tons of CO2 equivalent) of 2008?
Ensure brevity in your answer.  1143. What is the difference between the highest and the lowest PFC emissions (in thousand metric tons of CO2 equivalent) of 1990?
Your answer should be very brief. 2102.6. What is the difference between the highest and the lowest PFC emissions (in thousand metric tons of CO2 equivalent) of 2000?
Your answer should be very brief. 1918.3. What is the difference between the highest and the lowest PFC emissions (in thousand metric tons of CO2 equivalent) in 2005?
Offer a terse response. 1007.3. What is the difference between the highest and the lowest PFC emissions (in thousand metric tons of CO2 equivalent) of 2008?
Your answer should be very brief. 1468.2. 